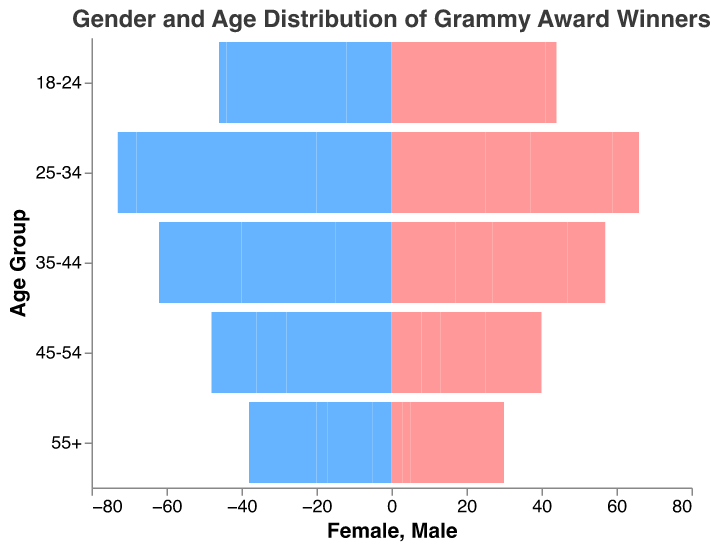What's the title of the figure? The title of the figure is displayed at the top and usually provides a summary of what the figure represents. In this case, it is specified in the 'title' section.
Answer: Gender and Age Distribution of Grammy Award Winners Which music category has the highest number of female winners aged 55+? To determine this, look at the female bar segment labeled "55+" across different categories. Compare the heights/values.
Answer: Classical In the Rock category, are there more male or female winners in the 25-34 age group? Look at the Rock category and compare the heights of the male and female bars in the 25-34 age group. The values are 30 for males and 12 for females.
Answer: Male What's the age group with the highest number of male winners in the R&B category? Check the R&B category and compare the heights/values of male bars across all age groups. The highest value is in the 25-34 age group with 18 male winners.
Answer: 25-34 How does the number of female winners aged 18-24 compare between Pop and Rock categories? Compare the heights/values of the female bars for the 18-24 age group in both the Pop and Rock categories. They are 18 for Pop and 8 for Rock.
Answer: Pop has more female winners What's the total number of female winners aged 45-54 across all categories? Sum up the values of the female bars in the 45-54 age group across all categories: 8 (Pop) + 5 (Rock) + 12 (R&B) + 15 (Classical).
Answer: 40 Which music category has the least gender disparity in the 35-44 age group? Calculate the difference between the number of male and female winners in the 35-44 age group for each category. The smallest difference is in Pop (15 males - 17 females = 2 difference).
Answer: Pop In the Classical category, what's the ratio of male to female winners in the 55+ age group? Look at the Classical category and compare the values for the 55+ age group. There are 18 males and 20 females. The ratio is 18:20, which simplifies to 9:10.
Answer: 9:10 Which age group has the smallest number of Grammy winners in the Pop category? Check the values for all age groups in the Pop category. The 55+ age group has the smallest total (5 males and 3 females).
Answer: 55+ In the R&B category, is the trend of gender distribution consistent across all age groups? Examine the R&B category bars. Females consistently outnumber males in all age groups.
Answer: Yes 